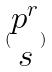<formula> <loc_0><loc_0><loc_500><loc_500>( \begin{matrix} p ^ { r } \\ s \end{matrix} )</formula> 